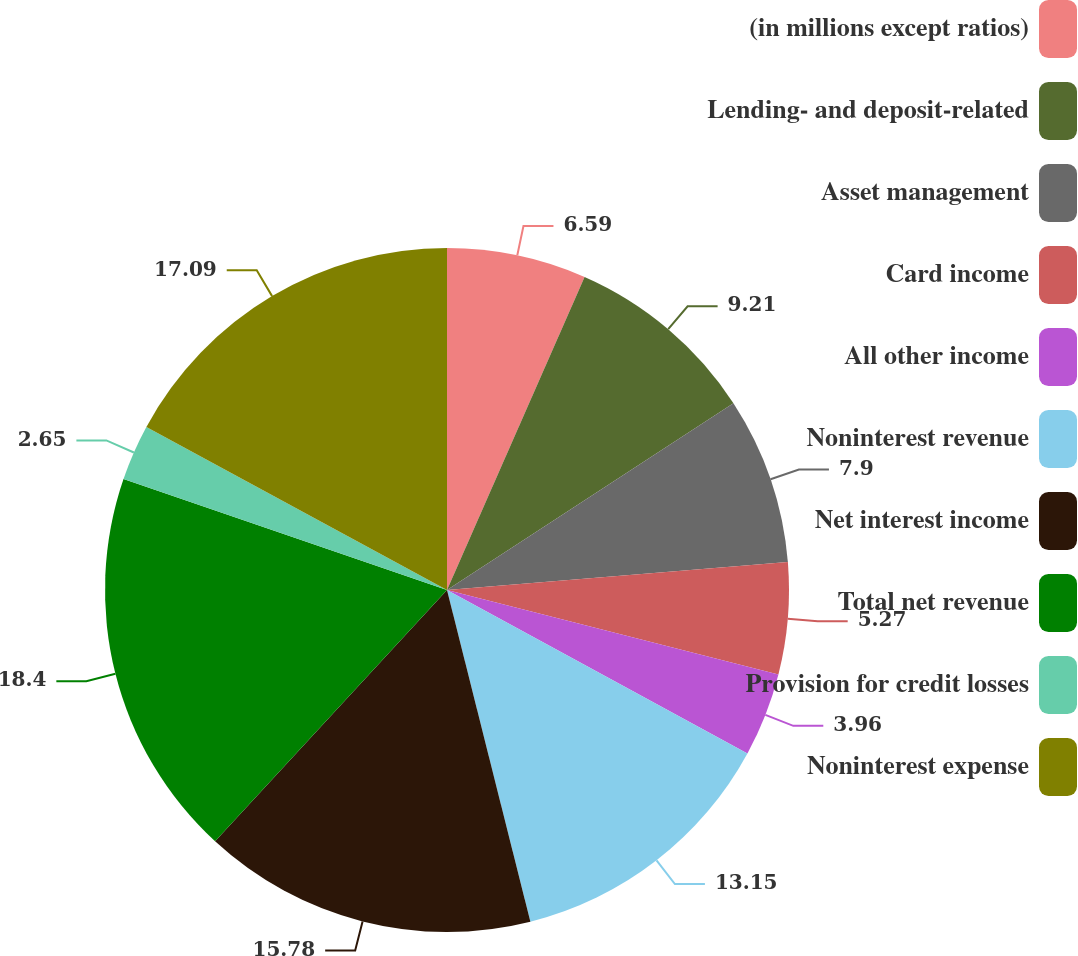Convert chart to OTSL. <chart><loc_0><loc_0><loc_500><loc_500><pie_chart><fcel>(in millions except ratios)<fcel>Lending- and deposit-related<fcel>Asset management<fcel>Card income<fcel>All other income<fcel>Noninterest revenue<fcel>Net interest income<fcel>Total net revenue<fcel>Provision for credit losses<fcel>Noninterest expense<nl><fcel>6.59%<fcel>9.21%<fcel>7.9%<fcel>5.27%<fcel>3.96%<fcel>13.15%<fcel>15.78%<fcel>18.4%<fcel>2.65%<fcel>17.09%<nl></chart> 